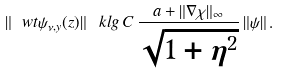Convert formula to latex. <formula><loc_0><loc_0><loc_500><loc_500>\| \ w t { \psi } _ { \nu , y } ( z ) \| \, \ k l g \, C \, \frac { a + \| \nabla \chi \| _ { \infty } } { \sqrt { 1 + \eta ^ { 2 } } } \, \| \psi \| \, .</formula> 